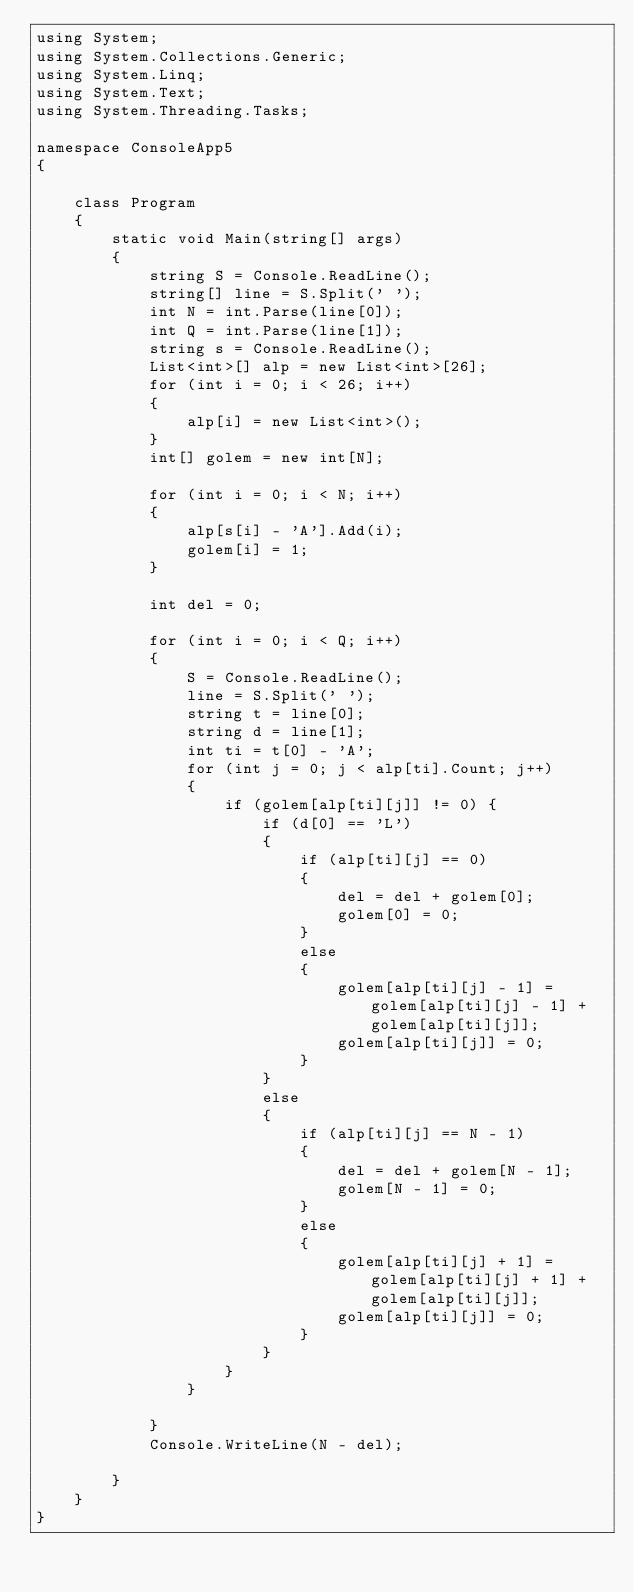Convert code to text. <code><loc_0><loc_0><loc_500><loc_500><_C#_>using System;
using System.Collections.Generic;
using System.Linq;
using System.Text;
using System.Threading.Tasks;

namespace ConsoleApp5
{

    class Program
    {
        static void Main(string[] args)
        {
            string S = Console.ReadLine();
            string[] line = S.Split(' ');
            int N = int.Parse(line[0]);
            int Q = int.Parse(line[1]);
            string s = Console.ReadLine();
            List<int>[] alp = new List<int>[26];
            for (int i = 0; i < 26; i++)
            {
                alp[i] = new List<int>();
            }
            int[] golem = new int[N];

            for (int i = 0; i < N; i++)
            {
                alp[s[i] - 'A'].Add(i);
                golem[i] = 1;
            }

            int del = 0;

            for (int i = 0; i < Q; i++)
            {
                S = Console.ReadLine();
                line = S.Split(' ');
                string t = line[0];
                string d = line[1];
                int ti = t[0] - 'A';
                for (int j = 0; j < alp[ti].Count; j++)
                {
                    if (golem[alp[ti][j]] != 0) { 
                        if (d[0] == 'L')
                        {
                            if (alp[ti][j] == 0)
                            {
                                del = del + golem[0];
                                golem[0] = 0;
                            }
                            else
                            {
                                golem[alp[ti][j] - 1] = golem[alp[ti][j] - 1] + golem[alp[ti][j]];
                                golem[alp[ti][j]] = 0;
                            }
                        }
                        else
                        {
                            if (alp[ti][j] == N - 1)
                            {
                                del = del + golem[N - 1];
                                golem[N - 1] = 0;
                            }
                            else
                            {
                                golem[alp[ti][j] + 1] = golem[alp[ti][j] + 1] + golem[alp[ti][j]];
                                golem[alp[ti][j]] = 0;
                            }
                        }
                    }
                }

            }
            Console.WriteLine(N - del);

        }
    }
}</code> 